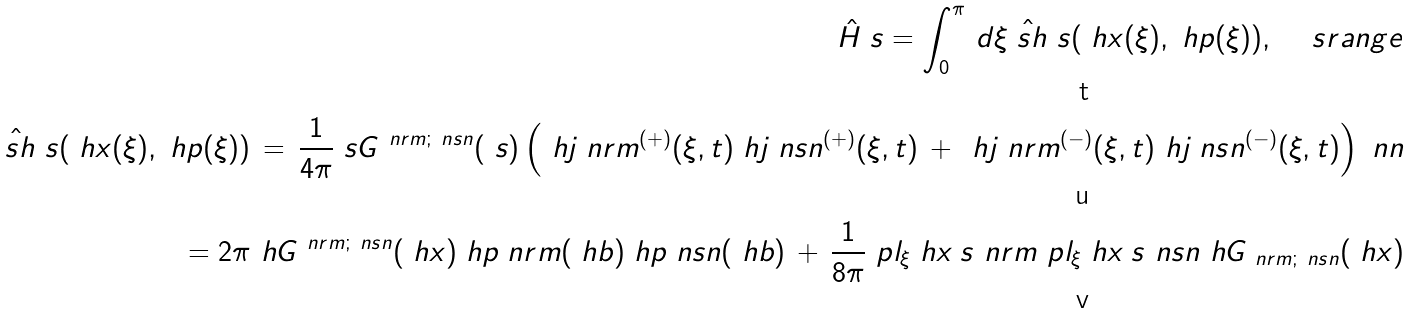Convert formula to latex. <formula><loc_0><loc_0><loc_500><loc_500>\hat { H } _ { \ } s = \int _ { 0 } ^ { \pi } \, d \xi \hat { \ s h } _ { \ } s ( \ h x ( \xi ) , \ h p ( \xi ) ) , \quad \ s r a n g e \\ \hat { \ s h } _ { \ } s ( \ h x ( \xi ) , \ h p ( \xi ) ) \, = \, \frac { 1 } { 4 \pi } \ s G ^ { \ n r m ; \ n s n } ( \ s ) \left ( \ h j _ { \ } n r m ^ { ( + ) } ( \xi , t ) \ h j _ { \ } n s n ^ { ( + ) } ( \xi , t ) \, + \, \ h j _ { \ } n r m ^ { ( - ) } ( \xi , t ) \ h j _ { \ } n s n ^ { ( - ) } ( \xi , t ) \right ) \ n n \\ \quad = 2 \pi \ h G ^ { \ n r m ; \ n s n } ( \ h x ) \ h p _ { \ } n r m ( \ h b ) \ h p _ { \ } n s n ( \ h b ) \, + \, \frac { 1 } { 8 \pi } \ p l _ { \xi } \ h x _ { \ } s ^ { \ } n r m \ p l _ { \xi } \ h x _ { \ } s ^ { \ } n s n \ h G _ { \ n r m ; \ n s n } ( \ h x )</formula> 